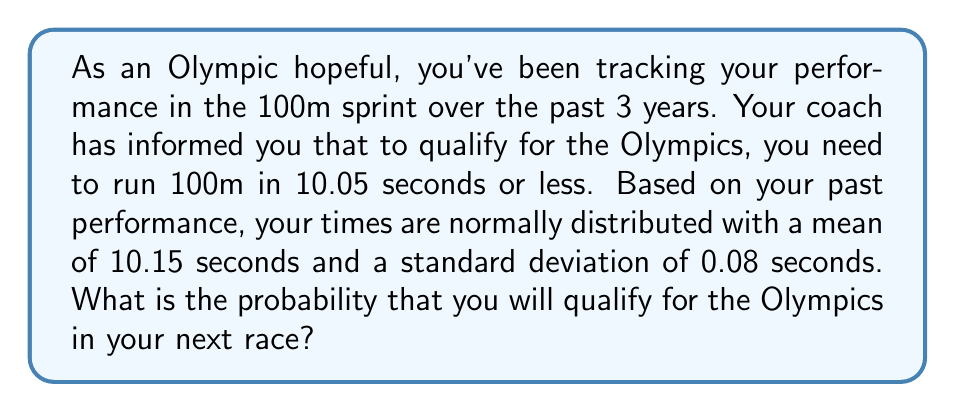Solve this math problem. To solve this problem, we need to use the concept of normal distribution and z-scores. Here's a step-by-step explanation:

1. Identify the given information:
   - Qualifying time: 10.05 seconds or less
   - Your times are normally distributed
   - Mean (μ) = 10.15 seconds
   - Standard deviation (σ) = 0.08 seconds

2. We need to find the probability of running 10.05 seconds or less. This is a "less than" probability problem.

3. Calculate the z-score for the qualifying time:
   $$ z = \frac{x - \mu}{\sigma} = \frac{10.05 - 10.15}{0.08} = -1.25 $$

4. The z-score of -1.25 represents the number of standard deviations the qualifying time is below the mean.

5. Use a standard normal distribution table or calculator to find the probability associated with this z-score. We're looking for the area to the left of z = -1.25.

6. From a standard normal distribution table or calculator, we find:
   $$ P(Z \leq -1.25) \approx 0.1056 $$

7. This probability represents the chance of running 10.05 seconds or less, which is the qualification criteria for the Olympics.
Answer: The probability of qualifying for the Olympics in your next race is approximately 0.1056 or 10.56%. 